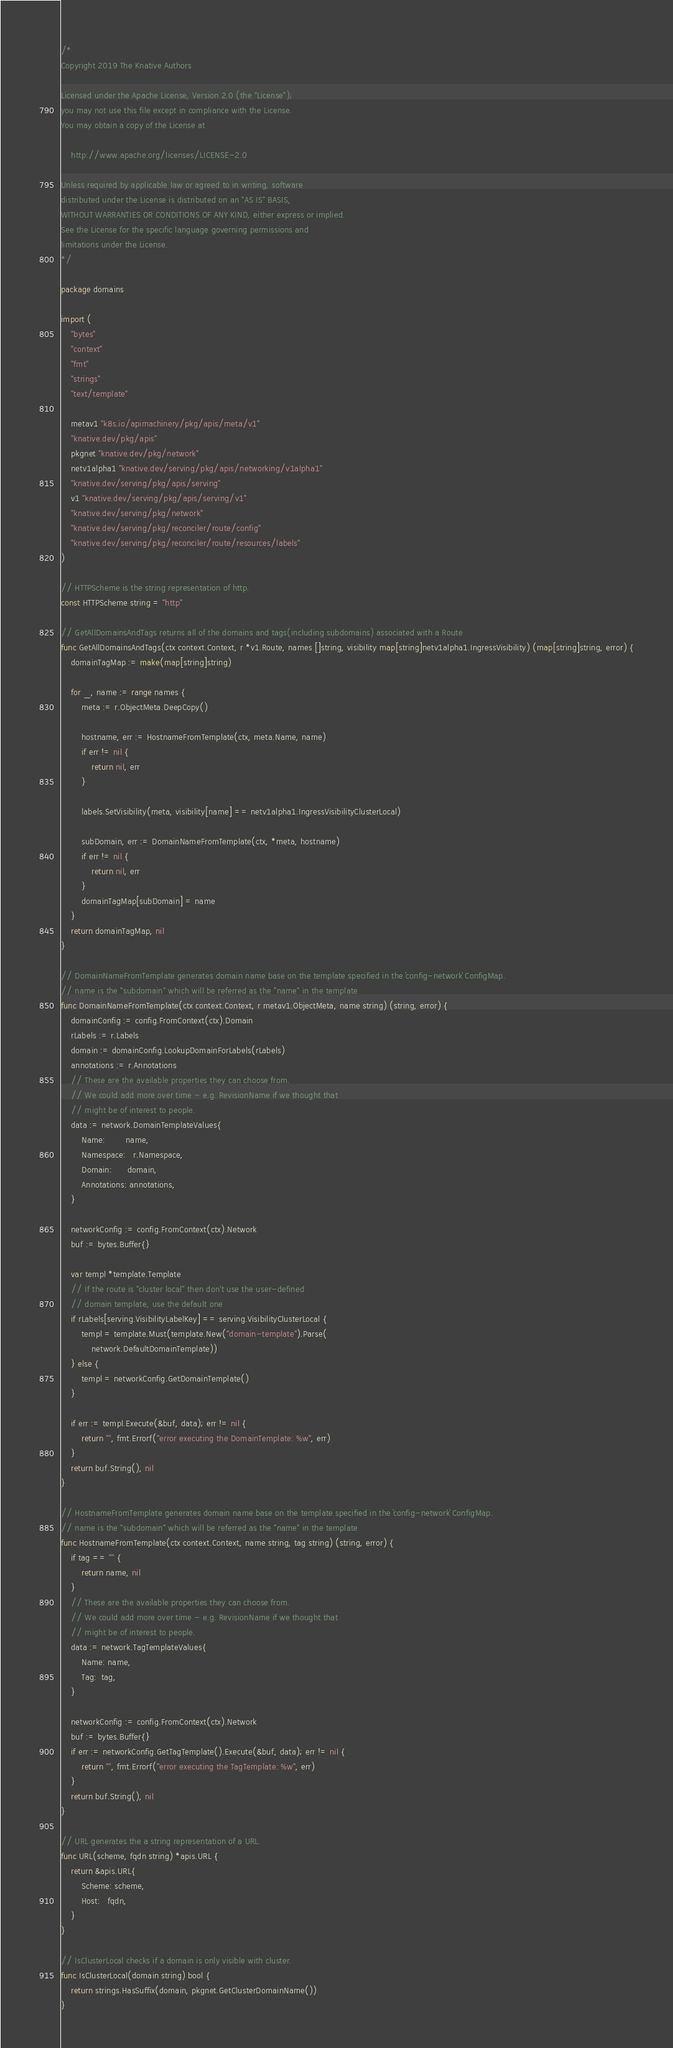<code> <loc_0><loc_0><loc_500><loc_500><_Go_>/*
Copyright 2019 The Knative Authors

Licensed under the Apache License, Version 2.0 (the "License");
you may not use this file except in compliance with the License.
You may obtain a copy of the License at

    http://www.apache.org/licenses/LICENSE-2.0

Unless required by applicable law or agreed to in writing, software
distributed under the License is distributed on an "AS IS" BASIS,
WITHOUT WARRANTIES OR CONDITIONS OF ANY KIND, either express or implied.
See the License for the specific language governing permissions and
limitations under the License.
*/

package domains

import (
	"bytes"
	"context"
	"fmt"
	"strings"
	"text/template"

	metav1 "k8s.io/apimachinery/pkg/apis/meta/v1"
	"knative.dev/pkg/apis"
	pkgnet "knative.dev/pkg/network"
	netv1alpha1 "knative.dev/serving/pkg/apis/networking/v1alpha1"
	"knative.dev/serving/pkg/apis/serving"
	v1 "knative.dev/serving/pkg/apis/serving/v1"
	"knative.dev/serving/pkg/network"
	"knative.dev/serving/pkg/reconciler/route/config"
	"knative.dev/serving/pkg/reconciler/route/resources/labels"
)

// HTTPScheme is the string representation of http.
const HTTPScheme string = "http"

// GetAllDomainsAndTags returns all of the domains and tags(including subdomains) associated with a Route
func GetAllDomainsAndTags(ctx context.Context, r *v1.Route, names []string, visibility map[string]netv1alpha1.IngressVisibility) (map[string]string, error) {
	domainTagMap := make(map[string]string)

	for _, name := range names {
		meta := r.ObjectMeta.DeepCopy()

		hostname, err := HostnameFromTemplate(ctx, meta.Name, name)
		if err != nil {
			return nil, err
		}

		labels.SetVisibility(meta, visibility[name] == netv1alpha1.IngressVisibilityClusterLocal)

		subDomain, err := DomainNameFromTemplate(ctx, *meta, hostname)
		if err != nil {
			return nil, err
		}
		domainTagMap[subDomain] = name
	}
	return domainTagMap, nil
}

// DomainNameFromTemplate generates domain name base on the template specified in the `config-network` ConfigMap.
// name is the "subdomain" which will be referred as the "name" in the template
func DomainNameFromTemplate(ctx context.Context, r metav1.ObjectMeta, name string) (string, error) {
	domainConfig := config.FromContext(ctx).Domain
	rLabels := r.Labels
	domain := domainConfig.LookupDomainForLabels(rLabels)
	annotations := r.Annotations
	// These are the available properties they can choose from.
	// We could add more over time - e.g. RevisionName if we thought that
	// might be of interest to people.
	data := network.DomainTemplateValues{
		Name:        name,
		Namespace:   r.Namespace,
		Domain:      domain,
		Annotations: annotations,
	}

	networkConfig := config.FromContext(ctx).Network
	buf := bytes.Buffer{}

	var templ *template.Template
	// If the route is "cluster local" then don't use the user-defined
	// domain template, use the default one
	if rLabels[serving.VisibilityLabelKey] == serving.VisibilityClusterLocal {
		templ = template.Must(template.New("domain-template").Parse(
			network.DefaultDomainTemplate))
	} else {
		templ = networkConfig.GetDomainTemplate()
	}

	if err := templ.Execute(&buf, data); err != nil {
		return "", fmt.Errorf("error executing the DomainTemplate: %w", err)
	}
	return buf.String(), nil
}

// HostnameFromTemplate generates domain name base on the template specified in the `config-network` ConfigMap.
// name is the "subdomain" which will be referred as the "name" in the template
func HostnameFromTemplate(ctx context.Context, name string, tag string) (string, error) {
	if tag == "" {
		return name, nil
	}
	// These are the available properties they can choose from.
	// We could add more over time - e.g. RevisionName if we thought that
	// might be of interest to people.
	data := network.TagTemplateValues{
		Name: name,
		Tag:  tag,
	}

	networkConfig := config.FromContext(ctx).Network
	buf := bytes.Buffer{}
	if err := networkConfig.GetTagTemplate().Execute(&buf, data); err != nil {
		return "", fmt.Errorf("error executing the TagTemplate: %w", err)
	}
	return buf.String(), nil
}

// URL generates the a string representation of a URL.
func URL(scheme, fqdn string) *apis.URL {
	return &apis.URL{
		Scheme: scheme,
		Host:   fqdn,
	}
}

// IsClusterLocal checks if a domain is only visible with cluster.
func IsClusterLocal(domain string) bool {
	return strings.HasSuffix(domain, pkgnet.GetClusterDomainName())
}
</code> 